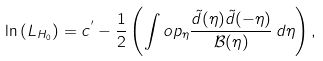Convert formula to latex. <formula><loc_0><loc_0><loc_500><loc_500>\ln \left ( L _ { H _ { 0 } } \right ) = c ^ { ^ { \prime } } - \frac { 1 } { 2 } \left ( \int o p _ { \eta } \frac { \tilde { d } ( \eta ) \tilde { d } ( - \eta ) } { \mathcal { B } ( \eta ) } \, d \eta \right ) ,</formula> 